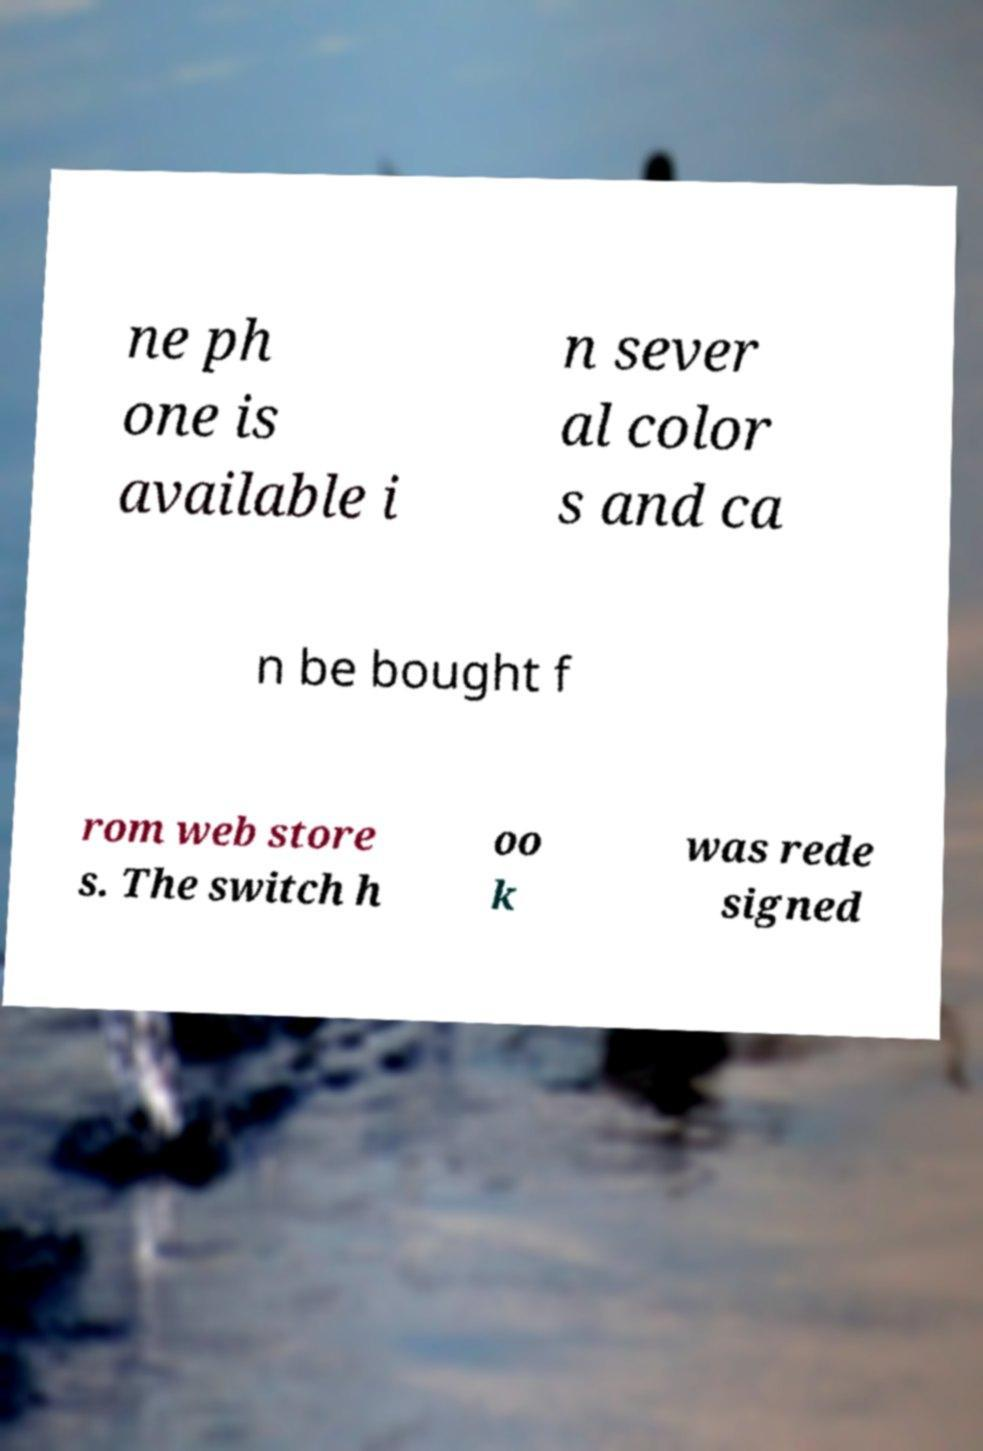Could you assist in decoding the text presented in this image and type it out clearly? ne ph one is available i n sever al color s and ca n be bought f rom web store s. The switch h oo k was rede signed 